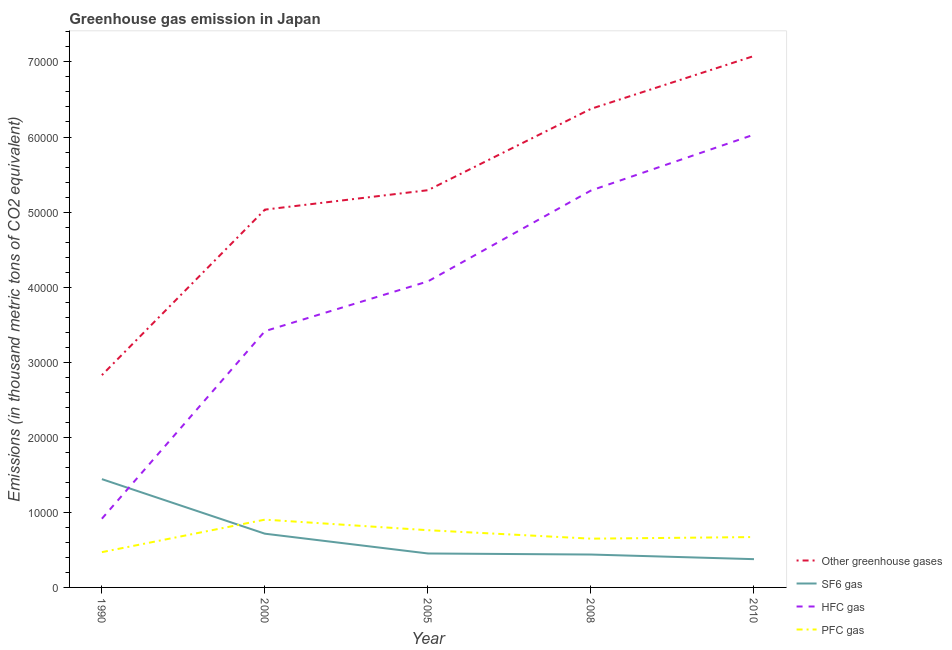Does the line corresponding to emission of hfc gas intersect with the line corresponding to emission of sf6 gas?
Give a very brief answer. Yes. What is the emission of greenhouse gases in 2005?
Offer a very short reply. 5.29e+04. Across all years, what is the maximum emission of pfc gas?
Your response must be concise. 9029.8. Across all years, what is the minimum emission of sf6 gas?
Your answer should be compact. 3765. In which year was the emission of hfc gas maximum?
Offer a terse response. 2010. What is the total emission of greenhouse gases in the graph?
Offer a very short reply. 2.66e+05. What is the difference between the emission of greenhouse gases in 1990 and that in 2010?
Give a very brief answer. -4.25e+04. What is the difference between the emission of pfc gas in 2010 and the emission of hfc gas in 1990?
Provide a short and direct response. -2444.3. What is the average emission of greenhouse gases per year?
Your answer should be very brief. 5.32e+04. In the year 2000, what is the difference between the emission of hfc gas and emission of pfc gas?
Give a very brief answer. 2.51e+04. In how many years, is the emission of sf6 gas greater than 6000 thousand metric tons?
Your answer should be compact. 2. What is the ratio of the emission of hfc gas in 2008 to that in 2010?
Give a very brief answer. 0.88. Is the difference between the emission of greenhouse gases in 2000 and 2008 greater than the difference between the emission of sf6 gas in 2000 and 2008?
Provide a short and direct response. No. What is the difference between the highest and the second highest emission of pfc gas?
Your response must be concise. 1406.2. What is the difference between the highest and the lowest emission of pfc gas?
Give a very brief answer. 4329.8. In how many years, is the emission of pfc gas greater than the average emission of pfc gas taken over all years?
Provide a short and direct response. 2. Is the sum of the emission of hfc gas in 1990 and 2000 greater than the maximum emission of sf6 gas across all years?
Provide a short and direct response. Yes. Is it the case that in every year, the sum of the emission of greenhouse gases and emission of hfc gas is greater than the sum of emission of pfc gas and emission of sf6 gas?
Keep it short and to the point. Yes. Does the emission of greenhouse gases monotonically increase over the years?
Your answer should be compact. Yes. Is the emission of pfc gas strictly less than the emission of sf6 gas over the years?
Offer a very short reply. No. How many lines are there?
Keep it short and to the point. 4. How many years are there in the graph?
Give a very brief answer. 5. Does the graph contain grids?
Offer a terse response. No. What is the title of the graph?
Ensure brevity in your answer.  Greenhouse gas emission in Japan. What is the label or title of the X-axis?
Give a very brief answer. Year. What is the label or title of the Y-axis?
Your answer should be compact. Emissions (in thousand metric tons of CO2 equivalent). What is the Emissions (in thousand metric tons of CO2 equivalent) of Other greenhouse gases in 1990?
Your answer should be compact. 2.83e+04. What is the Emissions (in thousand metric tons of CO2 equivalent) of SF6 gas in 1990?
Provide a succinct answer. 1.44e+04. What is the Emissions (in thousand metric tons of CO2 equivalent) of HFC gas in 1990?
Offer a terse response. 9154.3. What is the Emissions (in thousand metric tons of CO2 equivalent) of PFC gas in 1990?
Give a very brief answer. 4700. What is the Emissions (in thousand metric tons of CO2 equivalent) in Other greenhouse gases in 2000?
Your answer should be compact. 5.03e+04. What is the Emissions (in thousand metric tons of CO2 equivalent) in SF6 gas in 2000?
Offer a terse response. 7156.6. What is the Emissions (in thousand metric tons of CO2 equivalent) in HFC gas in 2000?
Ensure brevity in your answer.  3.41e+04. What is the Emissions (in thousand metric tons of CO2 equivalent) of PFC gas in 2000?
Keep it short and to the point. 9029.8. What is the Emissions (in thousand metric tons of CO2 equivalent) in Other greenhouse gases in 2005?
Your answer should be very brief. 5.29e+04. What is the Emissions (in thousand metric tons of CO2 equivalent) of SF6 gas in 2005?
Ensure brevity in your answer.  4522.3. What is the Emissions (in thousand metric tons of CO2 equivalent) of HFC gas in 2005?
Your response must be concise. 4.08e+04. What is the Emissions (in thousand metric tons of CO2 equivalent) in PFC gas in 2005?
Provide a succinct answer. 7623.6. What is the Emissions (in thousand metric tons of CO2 equivalent) in Other greenhouse gases in 2008?
Keep it short and to the point. 6.38e+04. What is the Emissions (in thousand metric tons of CO2 equivalent) in SF6 gas in 2008?
Provide a short and direct response. 4382.7. What is the Emissions (in thousand metric tons of CO2 equivalent) in HFC gas in 2008?
Keep it short and to the point. 5.29e+04. What is the Emissions (in thousand metric tons of CO2 equivalent) of PFC gas in 2008?
Ensure brevity in your answer.  6496.1. What is the Emissions (in thousand metric tons of CO2 equivalent) of Other greenhouse gases in 2010?
Your answer should be very brief. 7.08e+04. What is the Emissions (in thousand metric tons of CO2 equivalent) of SF6 gas in 2010?
Your response must be concise. 3765. What is the Emissions (in thousand metric tons of CO2 equivalent) in HFC gas in 2010?
Make the answer very short. 6.03e+04. What is the Emissions (in thousand metric tons of CO2 equivalent) in PFC gas in 2010?
Your response must be concise. 6710. Across all years, what is the maximum Emissions (in thousand metric tons of CO2 equivalent) of Other greenhouse gases?
Provide a short and direct response. 7.08e+04. Across all years, what is the maximum Emissions (in thousand metric tons of CO2 equivalent) of SF6 gas?
Your answer should be compact. 1.44e+04. Across all years, what is the maximum Emissions (in thousand metric tons of CO2 equivalent) in HFC gas?
Make the answer very short. 6.03e+04. Across all years, what is the maximum Emissions (in thousand metric tons of CO2 equivalent) in PFC gas?
Your answer should be very brief. 9029.8. Across all years, what is the minimum Emissions (in thousand metric tons of CO2 equivalent) in Other greenhouse gases?
Provide a succinct answer. 2.83e+04. Across all years, what is the minimum Emissions (in thousand metric tons of CO2 equivalent) in SF6 gas?
Keep it short and to the point. 3765. Across all years, what is the minimum Emissions (in thousand metric tons of CO2 equivalent) in HFC gas?
Ensure brevity in your answer.  9154.3. Across all years, what is the minimum Emissions (in thousand metric tons of CO2 equivalent) in PFC gas?
Your answer should be very brief. 4700. What is the total Emissions (in thousand metric tons of CO2 equivalent) of Other greenhouse gases in the graph?
Your response must be concise. 2.66e+05. What is the total Emissions (in thousand metric tons of CO2 equivalent) of SF6 gas in the graph?
Make the answer very short. 3.43e+04. What is the total Emissions (in thousand metric tons of CO2 equivalent) in HFC gas in the graph?
Offer a very short reply. 1.97e+05. What is the total Emissions (in thousand metric tons of CO2 equivalent) of PFC gas in the graph?
Provide a succinct answer. 3.46e+04. What is the difference between the Emissions (in thousand metric tons of CO2 equivalent) in Other greenhouse gases in 1990 and that in 2000?
Your answer should be compact. -2.20e+04. What is the difference between the Emissions (in thousand metric tons of CO2 equivalent) in SF6 gas in 1990 and that in 2000?
Your answer should be very brief. 7269.2. What is the difference between the Emissions (in thousand metric tons of CO2 equivalent) of HFC gas in 1990 and that in 2000?
Your response must be concise. -2.50e+04. What is the difference between the Emissions (in thousand metric tons of CO2 equivalent) of PFC gas in 1990 and that in 2000?
Your answer should be very brief. -4329.8. What is the difference between the Emissions (in thousand metric tons of CO2 equivalent) of Other greenhouse gases in 1990 and that in 2005?
Provide a succinct answer. -2.46e+04. What is the difference between the Emissions (in thousand metric tons of CO2 equivalent) in SF6 gas in 1990 and that in 2005?
Provide a succinct answer. 9903.5. What is the difference between the Emissions (in thousand metric tons of CO2 equivalent) in HFC gas in 1990 and that in 2005?
Offer a terse response. -3.16e+04. What is the difference between the Emissions (in thousand metric tons of CO2 equivalent) in PFC gas in 1990 and that in 2005?
Make the answer very short. -2923.6. What is the difference between the Emissions (in thousand metric tons of CO2 equivalent) in Other greenhouse gases in 1990 and that in 2008?
Provide a short and direct response. -3.55e+04. What is the difference between the Emissions (in thousand metric tons of CO2 equivalent) of SF6 gas in 1990 and that in 2008?
Offer a terse response. 1.00e+04. What is the difference between the Emissions (in thousand metric tons of CO2 equivalent) of HFC gas in 1990 and that in 2008?
Offer a terse response. -4.37e+04. What is the difference between the Emissions (in thousand metric tons of CO2 equivalent) of PFC gas in 1990 and that in 2008?
Your answer should be very brief. -1796.1. What is the difference between the Emissions (in thousand metric tons of CO2 equivalent) in Other greenhouse gases in 1990 and that in 2010?
Your answer should be compact. -4.25e+04. What is the difference between the Emissions (in thousand metric tons of CO2 equivalent) of SF6 gas in 1990 and that in 2010?
Ensure brevity in your answer.  1.07e+04. What is the difference between the Emissions (in thousand metric tons of CO2 equivalent) in HFC gas in 1990 and that in 2010?
Your response must be concise. -5.12e+04. What is the difference between the Emissions (in thousand metric tons of CO2 equivalent) in PFC gas in 1990 and that in 2010?
Give a very brief answer. -2010. What is the difference between the Emissions (in thousand metric tons of CO2 equivalent) in Other greenhouse gases in 2000 and that in 2005?
Give a very brief answer. -2588.2. What is the difference between the Emissions (in thousand metric tons of CO2 equivalent) in SF6 gas in 2000 and that in 2005?
Offer a very short reply. 2634.3. What is the difference between the Emissions (in thousand metric tons of CO2 equivalent) of HFC gas in 2000 and that in 2005?
Give a very brief answer. -6628.7. What is the difference between the Emissions (in thousand metric tons of CO2 equivalent) in PFC gas in 2000 and that in 2005?
Ensure brevity in your answer.  1406.2. What is the difference between the Emissions (in thousand metric tons of CO2 equivalent) of Other greenhouse gases in 2000 and that in 2008?
Your answer should be very brief. -1.34e+04. What is the difference between the Emissions (in thousand metric tons of CO2 equivalent) in SF6 gas in 2000 and that in 2008?
Your answer should be compact. 2773.9. What is the difference between the Emissions (in thousand metric tons of CO2 equivalent) in HFC gas in 2000 and that in 2008?
Your answer should be very brief. -1.87e+04. What is the difference between the Emissions (in thousand metric tons of CO2 equivalent) of PFC gas in 2000 and that in 2008?
Your answer should be very brief. 2533.7. What is the difference between the Emissions (in thousand metric tons of CO2 equivalent) in Other greenhouse gases in 2000 and that in 2010?
Provide a succinct answer. -2.05e+04. What is the difference between the Emissions (in thousand metric tons of CO2 equivalent) of SF6 gas in 2000 and that in 2010?
Give a very brief answer. 3391.6. What is the difference between the Emissions (in thousand metric tons of CO2 equivalent) of HFC gas in 2000 and that in 2010?
Keep it short and to the point. -2.62e+04. What is the difference between the Emissions (in thousand metric tons of CO2 equivalent) of PFC gas in 2000 and that in 2010?
Make the answer very short. 2319.8. What is the difference between the Emissions (in thousand metric tons of CO2 equivalent) in Other greenhouse gases in 2005 and that in 2008?
Ensure brevity in your answer.  -1.08e+04. What is the difference between the Emissions (in thousand metric tons of CO2 equivalent) of SF6 gas in 2005 and that in 2008?
Offer a terse response. 139.6. What is the difference between the Emissions (in thousand metric tons of CO2 equivalent) in HFC gas in 2005 and that in 2008?
Offer a terse response. -1.21e+04. What is the difference between the Emissions (in thousand metric tons of CO2 equivalent) in PFC gas in 2005 and that in 2008?
Your response must be concise. 1127.5. What is the difference between the Emissions (in thousand metric tons of CO2 equivalent) of Other greenhouse gases in 2005 and that in 2010?
Your response must be concise. -1.79e+04. What is the difference between the Emissions (in thousand metric tons of CO2 equivalent) of SF6 gas in 2005 and that in 2010?
Make the answer very short. 757.3. What is the difference between the Emissions (in thousand metric tons of CO2 equivalent) in HFC gas in 2005 and that in 2010?
Provide a short and direct response. -1.95e+04. What is the difference between the Emissions (in thousand metric tons of CO2 equivalent) of PFC gas in 2005 and that in 2010?
Your response must be concise. 913.6. What is the difference between the Emissions (in thousand metric tons of CO2 equivalent) in Other greenhouse gases in 2008 and that in 2010?
Offer a very short reply. -7042.3. What is the difference between the Emissions (in thousand metric tons of CO2 equivalent) of SF6 gas in 2008 and that in 2010?
Your response must be concise. 617.7. What is the difference between the Emissions (in thousand metric tons of CO2 equivalent) in HFC gas in 2008 and that in 2010?
Keep it short and to the point. -7446.1. What is the difference between the Emissions (in thousand metric tons of CO2 equivalent) in PFC gas in 2008 and that in 2010?
Your answer should be compact. -213.9. What is the difference between the Emissions (in thousand metric tons of CO2 equivalent) of Other greenhouse gases in 1990 and the Emissions (in thousand metric tons of CO2 equivalent) of SF6 gas in 2000?
Offer a terse response. 2.11e+04. What is the difference between the Emissions (in thousand metric tons of CO2 equivalent) of Other greenhouse gases in 1990 and the Emissions (in thousand metric tons of CO2 equivalent) of HFC gas in 2000?
Make the answer very short. -5859.7. What is the difference between the Emissions (in thousand metric tons of CO2 equivalent) of Other greenhouse gases in 1990 and the Emissions (in thousand metric tons of CO2 equivalent) of PFC gas in 2000?
Ensure brevity in your answer.  1.93e+04. What is the difference between the Emissions (in thousand metric tons of CO2 equivalent) in SF6 gas in 1990 and the Emissions (in thousand metric tons of CO2 equivalent) in HFC gas in 2000?
Your answer should be compact. -1.97e+04. What is the difference between the Emissions (in thousand metric tons of CO2 equivalent) in SF6 gas in 1990 and the Emissions (in thousand metric tons of CO2 equivalent) in PFC gas in 2000?
Provide a succinct answer. 5396. What is the difference between the Emissions (in thousand metric tons of CO2 equivalent) in HFC gas in 1990 and the Emissions (in thousand metric tons of CO2 equivalent) in PFC gas in 2000?
Your answer should be very brief. 124.5. What is the difference between the Emissions (in thousand metric tons of CO2 equivalent) in Other greenhouse gases in 1990 and the Emissions (in thousand metric tons of CO2 equivalent) in SF6 gas in 2005?
Make the answer very short. 2.38e+04. What is the difference between the Emissions (in thousand metric tons of CO2 equivalent) of Other greenhouse gases in 1990 and the Emissions (in thousand metric tons of CO2 equivalent) of HFC gas in 2005?
Give a very brief answer. -1.25e+04. What is the difference between the Emissions (in thousand metric tons of CO2 equivalent) of Other greenhouse gases in 1990 and the Emissions (in thousand metric tons of CO2 equivalent) of PFC gas in 2005?
Keep it short and to the point. 2.07e+04. What is the difference between the Emissions (in thousand metric tons of CO2 equivalent) of SF6 gas in 1990 and the Emissions (in thousand metric tons of CO2 equivalent) of HFC gas in 2005?
Offer a terse response. -2.63e+04. What is the difference between the Emissions (in thousand metric tons of CO2 equivalent) in SF6 gas in 1990 and the Emissions (in thousand metric tons of CO2 equivalent) in PFC gas in 2005?
Offer a very short reply. 6802.2. What is the difference between the Emissions (in thousand metric tons of CO2 equivalent) of HFC gas in 1990 and the Emissions (in thousand metric tons of CO2 equivalent) of PFC gas in 2005?
Your response must be concise. 1530.7. What is the difference between the Emissions (in thousand metric tons of CO2 equivalent) in Other greenhouse gases in 1990 and the Emissions (in thousand metric tons of CO2 equivalent) in SF6 gas in 2008?
Your answer should be very brief. 2.39e+04. What is the difference between the Emissions (in thousand metric tons of CO2 equivalent) of Other greenhouse gases in 1990 and the Emissions (in thousand metric tons of CO2 equivalent) of HFC gas in 2008?
Offer a terse response. -2.46e+04. What is the difference between the Emissions (in thousand metric tons of CO2 equivalent) in Other greenhouse gases in 1990 and the Emissions (in thousand metric tons of CO2 equivalent) in PFC gas in 2008?
Keep it short and to the point. 2.18e+04. What is the difference between the Emissions (in thousand metric tons of CO2 equivalent) of SF6 gas in 1990 and the Emissions (in thousand metric tons of CO2 equivalent) of HFC gas in 2008?
Your answer should be very brief. -3.84e+04. What is the difference between the Emissions (in thousand metric tons of CO2 equivalent) of SF6 gas in 1990 and the Emissions (in thousand metric tons of CO2 equivalent) of PFC gas in 2008?
Offer a very short reply. 7929.7. What is the difference between the Emissions (in thousand metric tons of CO2 equivalent) in HFC gas in 1990 and the Emissions (in thousand metric tons of CO2 equivalent) in PFC gas in 2008?
Ensure brevity in your answer.  2658.2. What is the difference between the Emissions (in thousand metric tons of CO2 equivalent) of Other greenhouse gases in 1990 and the Emissions (in thousand metric tons of CO2 equivalent) of SF6 gas in 2010?
Provide a short and direct response. 2.45e+04. What is the difference between the Emissions (in thousand metric tons of CO2 equivalent) in Other greenhouse gases in 1990 and the Emissions (in thousand metric tons of CO2 equivalent) in HFC gas in 2010?
Ensure brevity in your answer.  -3.20e+04. What is the difference between the Emissions (in thousand metric tons of CO2 equivalent) in Other greenhouse gases in 1990 and the Emissions (in thousand metric tons of CO2 equivalent) in PFC gas in 2010?
Make the answer very short. 2.16e+04. What is the difference between the Emissions (in thousand metric tons of CO2 equivalent) in SF6 gas in 1990 and the Emissions (in thousand metric tons of CO2 equivalent) in HFC gas in 2010?
Make the answer very short. -4.59e+04. What is the difference between the Emissions (in thousand metric tons of CO2 equivalent) of SF6 gas in 1990 and the Emissions (in thousand metric tons of CO2 equivalent) of PFC gas in 2010?
Ensure brevity in your answer.  7715.8. What is the difference between the Emissions (in thousand metric tons of CO2 equivalent) of HFC gas in 1990 and the Emissions (in thousand metric tons of CO2 equivalent) of PFC gas in 2010?
Give a very brief answer. 2444.3. What is the difference between the Emissions (in thousand metric tons of CO2 equivalent) in Other greenhouse gases in 2000 and the Emissions (in thousand metric tons of CO2 equivalent) in SF6 gas in 2005?
Ensure brevity in your answer.  4.58e+04. What is the difference between the Emissions (in thousand metric tons of CO2 equivalent) of Other greenhouse gases in 2000 and the Emissions (in thousand metric tons of CO2 equivalent) of HFC gas in 2005?
Your answer should be very brief. 9557.7. What is the difference between the Emissions (in thousand metric tons of CO2 equivalent) in Other greenhouse gases in 2000 and the Emissions (in thousand metric tons of CO2 equivalent) in PFC gas in 2005?
Give a very brief answer. 4.27e+04. What is the difference between the Emissions (in thousand metric tons of CO2 equivalent) of SF6 gas in 2000 and the Emissions (in thousand metric tons of CO2 equivalent) of HFC gas in 2005?
Your response must be concise. -3.36e+04. What is the difference between the Emissions (in thousand metric tons of CO2 equivalent) of SF6 gas in 2000 and the Emissions (in thousand metric tons of CO2 equivalent) of PFC gas in 2005?
Offer a terse response. -467. What is the difference between the Emissions (in thousand metric tons of CO2 equivalent) of HFC gas in 2000 and the Emissions (in thousand metric tons of CO2 equivalent) of PFC gas in 2005?
Make the answer very short. 2.65e+04. What is the difference between the Emissions (in thousand metric tons of CO2 equivalent) in Other greenhouse gases in 2000 and the Emissions (in thousand metric tons of CO2 equivalent) in SF6 gas in 2008?
Provide a short and direct response. 4.59e+04. What is the difference between the Emissions (in thousand metric tons of CO2 equivalent) of Other greenhouse gases in 2000 and the Emissions (in thousand metric tons of CO2 equivalent) of HFC gas in 2008?
Make the answer very short. -2545.7. What is the difference between the Emissions (in thousand metric tons of CO2 equivalent) in Other greenhouse gases in 2000 and the Emissions (in thousand metric tons of CO2 equivalent) in PFC gas in 2008?
Your response must be concise. 4.38e+04. What is the difference between the Emissions (in thousand metric tons of CO2 equivalent) of SF6 gas in 2000 and the Emissions (in thousand metric tons of CO2 equivalent) of HFC gas in 2008?
Your response must be concise. -4.57e+04. What is the difference between the Emissions (in thousand metric tons of CO2 equivalent) in SF6 gas in 2000 and the Emissions (in thousand metric tons of CO2 equivalent) in PFC gas in 2008?
Offer a terse response. 660.5. What is the difference between the Emissions (in thousand metric tons of CO2 equivalent) of HFC gas in 2000 and the Emissions (in thousand metric tons of CO2 equivalent) of PFC gas in 2008?
Provide a succinct answer. 2.76e+04. What is the difference between the Emissions (in thousand metric tons of CO2 equivalent) of Other greenhouse gases in 2000 and the Emissions (in thousand metric tons of CO2 equivalent) of SF6 gas in 2010?
Provide a succinct answer. 4.66e+04. What is the difference between the Emissions (in thousand metric tons of CO2 equivalent) in Other greenhouse gases in 2000 and the Emissions (in thousand metric tons of CO2 equivalent) in HFC gas in 2010?
Your response must be concise. -9991.8. What is the difference between the Emissions (in thousand metric tons of CO2 equivalent) in Other greenhouse gases in 2000 and the Emissions (in thousand metric tons of CO2 equivalent) in PFC gas in 2010?
Make the answer very short. 4.36e+04. What is the difference between the Emissions (in thousand metric tons of CO2 equivalent) of SF6 gas in 2000 and the Emissions (in thousand metric tons of CO2 equivalent) of HFC gas in 2010?
Your response must be concise. -5.32e+04. What is the difference between the Emissions (in thousand metric tons of CO2 equivalent) of SF6 gas in 2000 and the Emissions (in thousand metric tons of CO2 equivalent) of PFC gas in 2010?
Make the answer very short. 446.6. What is the difference between the Emissions (in thousand metric tons of CO2 equivalent) of HFC gas in 2000 and the Emissions (in thousand metric tons of CO2 equivalent) of PFC gas in 2010?
Your response must be concise. 2.74e+04. What is the difference between the Emissions (in thousand metric tons of CO2 equivalent) in Other greenhouse gases in 2005 and the Emissions (in thousand metric tons of CO2 equivalent) in SF6 gas in 2008?
Ensure brevity in your answer.  4.85e+04. What is the difference between the Emissions (in thousand metric tons of CO2 equivalent) of Other greenhouse gases in 2005 and the Emissions (in thousand metric tons of CO2 equivalent) of HFC gas in 2008?
Offer a very short reply. 42.5. What is the difference between the Emissions (in thousand metric tons of CO2 equivalent) of Other greenhouse gases in 2005 and the Emissions (in thousand metric tons of CO2 equivalent) of PFC gas in 2008?
Keep it short and to the point. 4.64e+04. What is the difference between the Emissions (in thousand metric tons of CO2 equivalent) in SF6 gas in 2005 and the Emissions (in thousand metric tons of CO2 equivalent) in HFC gas in 2008?
Keep it short and to the point. -4.83e+04. What is the difference between the Emissions (in thousand metric tons of CO2 equivalent) in SF6 gas in 2005 and the Emissions (in thousand metric tons of CO2 equivalent) in PFC gas in 2008?
Offer a terse response. -1973.8. What is the difference between the Emissions (in thousand metric tons of CO2 equivalent) in HFC gas in 2005 and the Emissions (in thousand metric tons of CO2 equivalent) in PFC gas in 2008?
Your answer should be very brief. 3.43e+04. What is the difference between the Emissions (in thousand metric tons of CO2 equivalent) in Other greenhouse gases in 2005 and the Emissions (in thousand metric tons of CO2 equivalent) in SF6 gas in 2010?
Offer a very short reply. 4.91e+04. What is the difference between the Emissions (in thousand metric tons of CO2 equivalent) of Other greenhouse gases in 2005 and the Emissions (in thousand metric tons of CO2 equivalent) of HFC gas in 2010?
Your response must be concise. -7403.6. What is the difference between the Emissions (in thousand metric tons of CO2 equivalent) of Other greenhouse gases in 2005 and the Emissions (in thousand metric tons of CO2 equivalent) of PFC gas in 2010?
Offer a terse response. 4.62e+04. What is the difference between the Emissions (in thousand metric tons of CO2 equivalent) in SF6 gas in 2005 and the Emissions (in thousand metric tons of CO2 equivalent) in HFC gas in 2010?
Your answer should be very brief. -5.58e+04. What is the difference between the Emissions (in thousand metric tons of CO2 equivalent) in SF6 gas in 2005 and the Emissions (in thousand metric tons of CO2 equivalent) in PFC gas in 2010?
Keep it short and to the point. -2187.7. What is the difference between the Emissions (in thousand metric tons of CO2 equivalent) in HFC gas in 2005 and the Emissions (in thousand metric tons of CO2 equivalent) in PFC gas in 2010?
Your response must be concise. 3.41e+04. What is the difference between the Emissions (in thousand metric tons of CO2 equivalent) of Other greenhouse gases in 2008 and the Emissions (in thousand metric tons of CO2 equivalent) of SF6 gas in 2010?
Make the answer very short. 6.00e+04. What is the difference between the Emissions (in thousand metric tons of CO2 equivalent) in Other greenhouse gases in 2008 and the Emissions (in thousand metric tons of CO2 equivalent) in HFC gas in 2010?
Your answer should be very brief. 3432.7. What is the difference between the Emissions (in thousand metric tons of CO2 equivalent) in Other greenhouse gases in 2008 and the Emissions (in thousand metric tons of CO2 equivalent) in PFC gas in 2010?
Ensure brevity in your answer.  5.70e+04. What is the difference between the Emissions (in thousand metric tons of CO2 equivalent) of SF6 gas in 2008 and the Emissions (in thousand metric tons of CO2 equivalent) of HFC gas in 2010?
Provide a short and direct response. -5.59e+04. What is the difference between the Emissions (in thousand metric tons of CO2 equivalent) of SF6 gas in 2008 and the Emissions (in thousand metric tons of CO2 equivalent) of PFC gas in 2010?
Make the answer very short. -2327.3. What is the difference between the Emissions (in thousand metric tons of CO2 equivalent) in HFC gas in 2008 and the Emissions (in thousand metric tons of CO2 equivalent) in PFC gas in 2010?
Give a very brief answer. 4.62e+04. What is the average Emissions (in thousand metric tons of CO2 equivalent) of Other greenhouse gases per year?
Your answer should be compact. 5.32e+04. What is the average Emissions (in thousand metric tons of CO2 equivalent) of SF6 gas per year?
Offer a very short reply. 6850.48. What is the average Emissions (in thousand metric tons of CO2 equivalent) in HFC gas per year?
Keep it short and to the point. 3.95e+04. What is the average Emissions (in thousand metric tons of CO2 equivalent) of PFC gas per year?
Provide a succinct answer. 6911.9. In the year 1990, what is the difference between the Emissions (in thousand metric tons of CO2 equivalent) of Other greenhouse gases and Emissions (in thousand metric tons of CO2 equivalent) of SF6 gas?
Keep it short and to the point. 1.39e+04. In the year 1990, what is the difference between the Emissions (in thousand metric tons of CO2 equivalent) in Other greenhouse gases and Emissions (in thousand metric tons of CO2 equivalent) in HFC gas?
Offer a very short reply. 1.91e+04. In the year 1990, what is the difference between the Emissions (in thousand metric tons of CO2 equivalent) of Other greenhouse gases and Emissions (in thousand metric tons of CO2 equivalent) of PFC gas?
Give a very brief answer. 2.36e+04. In the year 1990, what is the difference between the Emissions (in thousand metric tons of CO2 equivalent) in SF6 gas and Emissions (in thousand metric tons of CO2 equivalent) in HFC gas?
Give a very brief answer. 5271.5. In the year 1990, what is the difference between the Emissions (in thousand metric tons of CO2 equivalent) of SF6 gas and Emissions (in thousand metric tons of CO2 equivalent) of PFC gas?
Offer a terse response. 9725.8. In the year 1990, what is the difference between the Emissions (in thousand metric tons of CO2 equivalent) in HFC gas and Emissions (in thousand metric tons of CO2 equivalent) in PFC gas?
Provide a short and direct response. 4454.3. In the year 2000, what is the difference between the Emissions (in thousand metric tons of CO2 equivalent) of Other greenhouse gases and Emissions (in thousand metric tons of CO2 equivalent) of SF6 gas?
Keep it short and to the point. 4.32e+04. In the year 2000, what is the difference between the Emissions (in thousand metric tons of CO2 equivalent) of Other greenhouse gases and Emissions (in thousand metric tons of CO2 equivalent) of HFC gas?
Offer a terse response. 1.62e+04. In the year 2000, what is the difference between the Emissions (in thousand metric tons of CO2 equivalent) in Other greenhouse gases and Emissions (in thousand metric tons of CO2 equivalent) in PFC gas?
Provide a succinct answer. 4.13e+04. In the year 2000, what is the difference between the Emissions (in thousand metric tons of CO2 equivalent) of SF6 gas and Emissions (in thousand metric tons of CO2 equivalent) of HFC gas?
Provide a succinct answer. -2.70e+04. In the year 2000, what is the difference between the Emissions (in thousand metric tons of CO2 equivalent) in SF6 gas and Emissions (in thousand metric tons of CO2 equivalent) in PFC gas?
Provide a succinct answer. -1873.2. In the year 2000, what is the difference between the Emissions (in thousand metric tons of CO2 equivalent) of HFC gas and Emissions (in thousand metric tons of CO2 equivalent) of PFC gas?
Make the answer very short. 2.51e+04. In the year 2005, what is the difference between the Emissions (in thousand metric tons of CO2 equivalent) of Other greenhouse gases and Emissions (in thousand metric tons of CO2 equivalent) of SF6 gas?
Give a very brief answer. 4.84e+04. In the year 2005, what is the difference between the Emissions (in thousand metric tons of CO2 equivalent) in Other greenhouse gases and Emissions (in thousand metric tons of CO2 equivalent) in HFC gas?
Your response must be concise. 1.21e+04. In the year 2005, what is the difference between the Emissions (in thousand metric tons of CO2 equivalent) of Other greenhouse gases and Emissions (in thousand metric tons of CO2 equivalent) of PFC gas?
Offer a terse response. 4.53e+04. In the year 2005, what is the difference between the Emissions (in thousand metric tons of CO2 equivalent) of SF6 gas and Emissions (in thousand metric tons of CO2 equivalent) of HFC gas?
Make the answer very short. -3.62e+04. In the year 2005, what is the difference between the Emissions (in thousand metric tons of CO2 equivalent) of SF6 gas and Emissions (in thousand metric tons of CO2 equivalent) of PFC gas?
Your answer should be very brief. -3101.3. In the year 2005, what is the difference between the Emissions (in thousand metric tons of CO2 equivalent) of HFC gas and Emissions (in thousand metric tons of CO2 equivalent) of PFC gas?
Make the answer very short. 3.31e+04. In the year 2008, what is the difference between the Emissions (in thousand metric tons of CO2 equivalent) in Other greenhouse gases and Emissions (in thousand metric tons of CO2 equivalent) in SF6 gas?
Offer a very short reply. 5.94e+04. In the year 2008, what is the difference between the Emissions (in thousand metric tons of CO2 equivalent) of Other greenhouse gases and Emissions (in thousand metric tons of CO2 equivalent) of HFC gas?
Your response must be concise. 1.09e+04. In the year 2008, what is the difference between the Emissions (in thousand metric tons of CO2 equivalent) in Other greenhouse gases and Emissions (in thousand metric tons of CO2 equivalent) in PFC gas?
Give a very brief answer. 5.73e+04. In the year 2008, what is the difference between the Emissions (in thousand metric tons of CO2 equivalent) in SF6 gas and Emissions (in thousand metric tons of CO2 equivalent) in HFC gas?
Offer a terse response. -4.85e+04. In the year 2008, what is the difference between the Emissions (in thousand metric tons of CO2 equivalent) of SF6 gas and Emissions (in thousand metric tons of CO2 equivalent) of PFC gas?
Make the answer very short. -2113.4. In the year 2008, what is the difference between the Emissions (in thousand metric tons of CO2 equivalent) of HFC gas and Emissions (in thousand metric tons of CO2 equivalent) of PFC gas?
Offer a terse response. 4.64e+04. In the year 2010, what is the difference between the Emissions (in thousand metric tons of CO2 equivalent) in Other greenhouse gases and Emissions (in thousand metric tons of CO2 equivalent) in SF6 gas?
Make the answer very short. 6.70e+04. In the year 2010, what is the difference between the Emissions (in thousand metric tons of CO2 equivalent) in Other greenhouse gases and Emissions (in thousand metric tons of CO2 equivalent) in HFC gas?
Provide a succinct answer. 1.05e+04. In the year 2010, what is the difference between the Emissions (in thousand metric tons of CO2 equivalent) in Other greenhouse gases and Emissions (in thousand metric tons of CO2 equivalent) in PFC gas?
Provide a short and direct response. 6.41e+04. In the year 2010, what is the difference between the Emissions (in thousand metric tons of CO2 equivalent) in SF6 gas and Emissions (in thousand metric tons of CO2 equivalent) in HFC gas?
Your answer should be compact. -5.66e+04. In the year 2010, what is the difference between the Emissions (in thousand metric tons of CO2 equivalent) of SF6 gas and Emissions (in thousand metric tons of CO2 equivalent) of PFC gas?
Provide a succinct answer. -2945. In the year 2010, what is the difference between the Emissions (in thousand metric tons of CO2 equivalent) in HFC gas and Emissions (in thousand metric tons of CO2 equivalent) in PFC gas?
Provide a short and direct response. 5.36e+04. What is the ratio of the Emissions (in thousand metric tons of CO2 equivalent) of Other greenhouse gases in 1990 to that in 2000?
Ensure brevity in your answer.  0.56. What is the ratio of the Emissions (in thousand metric tons of CO2 equivalent) in SF6 gas in 1990 to that in 2000?
Your response must be concise. 2.02. What is the ratio of the Emissions (in thousand metric tons of CO2 equivalent) in HFC gas in 1990 to that in 2000?
Offer a terse response. 0.27. What is the ratio of the Emissions (in thousand metric tons of CO2 equivalent) in PFC gas in 1990 to that in 2000?
Provide a short and direct response. 0.52. What is the ratio of the Emissions (in thousand metric tons of CO2 equivalent) in Other greenhouse gases in 1990 to that in 2005?
Offer a terse response. 0.53. What is the ratio of the Emissions (in thousand metric tons of CO2 equivalent) of SF6 gas in 1990 to that in 2005?
Your answer should be compact. 3.19. What is the ratio of the Emissions (in thousand metric tons of CO2 equivalent) in HFC gas in 1990 to that in 2005?
Provide a short and direct response. 0.22. What is the ratio of the Emissions (in thousand metric tons of CO2 equivalent) of PFC gas in 1990 to that in 2005?
Your answer should be compact. 0.62. What is the ratio of the Emissions (in thousand metric tons of CO2 equivalent) of Other greenhouse gases in 1990 to that in 2008?
Give a very brief answer. 0.44. What is the ratio of the Emissions (in thousand metric tons of CO2 equivalent) in SF6 gas in 1990 to that in 2008?
Provide a short and direct response. 3.29. What is the ratio of the Emissions (in thousand metric tons of CO2 equivalent) of HFC gas in 1990 to that in 2008?
Provide a short and direct response. 0.17. What is the ratio of the Emissions (in thousand metric tons of CO2 equivalent) in PFC gas in 1990 to that in 2008?
Offer a terse response. 0.72. What is the ratio of the Emissions (in thousand metric tons of CO2 equivalent) in Other greenhouse gases in 1990 to that in 2010?
Your answer should be very brief. 0.4. What is the ratio of the Emissions (in thousand metric tons of CO2 equivalent) of SF6 gas in 1990 to that in 2010?
Your answer should be very brief. 3.83. What is the ratio of the Emissions (in thousand metric tons of CO2 equivalent) in HFC gas in 1990 to that in 2010?
Give a very brief answer. 0.15. What is the ratio of the Emissions (in thousand metric tons of CO2 equivalent) of PFC gas in 1990 to that in 2010?
Offer a terse response. 0.7. What is the ratio of the Emissions (in thousand metric tons of CO2 equivalent) of Other greenhouse gases in 2000 to that in 2005?
Offer a very short reply. 0.95. What is the ratio of the Emissions (in thousand metric tons of CO2 equivalent) of SF6 gas in 2000 to that in 2005?
Offer a very short reply. 1.58. What is the ratio of the Emissions (in thousand metric tons of CO2 equivalent) in HFC gas in 2000 to that in 2005?
Your answer should be very brief. 0.84. What is the ratio of the Emissions (in thousand metric tons of CO2 equivalent) in PFC gas in 2000 to that in 2005?
Ensure brevity in your answer.  1.18. What is the ratio of the Emissions (in thousand metric tons of CO2 equivalent) in Other greenhouse gases in 2000 to that in 2008?
Provide a succinct answer. 0.79. What is the ratio of the Emissions (in thousand metric tons of CO2 equivalent) in SF6 gas in 2000 to that in 2008?
Provide a succinct answer. 1.63. What is the ratio of the Emissions (in thousand metric tons of CO2 equivalent) of HFC gas in 2000 to that in 2008?
Your answer should be very brief. 0.65. What is the ratio of the Emissions (in thousand metric tons of CO2 equivalent) in PFC gas in 2000 to that in 2008?
Make the answer very short. 1.39. What is the ratio of the Emissions (in thousand metric tons of CO2 equivalent) in Other greenhouse gases in 2000 to that in 2010?
Provide a succinct answer. 0.71. What is the ratio of the Emissions (in thousand metric tons of CO2 equivalent) of SF6 gas in 2000 to that in 2010?
Provide a short and direct response. 1.9. What is the ratio of the Emissions (in thousand metric tons of CO2 equivalent) of HFC gas in 2000 to that in 2010?
Offer a terse response. 0.57. What is the ratio of the Emissions (in thousand metric tons of CO2 equivalent) in PFC gas in 2000 to that in 2010?
Give a very brief answer. 1.35. What is the ratio of the Emissions (in thousand metric tons of CO2 equivalent) of Other greenhouse gases in 2005 to that in 2008?
Keep it short and to the point. 0.83. What is the ratio of the Emissions (in thousand metric tons of CO2 equivalent) of SF6 gas in 2005 to that in 2008?
Make the answer very short. 1.03. What is the ratio of the Emissions (in thousand metric tons of CO2 equivalent) of HFC gas in 2005 to that in 2008?
Your answer should be very brief. 0.77. What is the ratio of the Emissions (in thousand metric tons of CO2 equivalent) of PFC gas in 2005 to that in 2008?
Make the answer very short. 1.17. What is the ratio of the Emissions (in thousand metric tons of CO2 equivalent) of Other greenhouse gases in 2005 to that in 2010?
Your answer should be compact. 0.75. What is the ratio of the Emissions (in thousand metric tons of CO2 equivalent) in SF6 gas in 2005 to that in 2010?
Provide a succinct answer. 1.2. What is the ratio of the Emissions (in thousand metric tons of CO2 equivalent) in HFC gas in 2005 to that in 2010?
Offer a terse response. 0.68. What is the ratio of the Emissions (in thousand metric tons of CO2 equivalent) of PFC gas in 2005 to that in 2010?
Provide a succinct answer. 1.14. What is the ratio of the Emissions (in thousand metric tons of CO2 equivalent) in Other greenhouse gases in 2008 to that in 2010?
Your answer should be compact. 0.9. What is the ratio of the Emissions (in thousand metric tons of CO2 equivalent) in SF6 gas in 2008 to that in 2010?
Ensure brevity in your answer.  1.16. What is the ratio of the Emissions (in thousand metric tons of CO2 equivalent) of HFC gas in 2008 to that in 2010?
Ensure brevity in your answer.  0.88. What is the ratio of the Emissions (in thousand metric tons of CO2 equivalent) of PFC gas in 2008 to that in 2010?
Your response must be concise. 0.97. What is the difference between the highest and the second highest Emissions (in thousand metric tons of CO2 equivalent) in Other greenhouse gases?
Keep it short and to the point. 7042.3. What is the difference between the highest and the second highest Emissions (in thousand metric tons of CO2 equivalent) in SF6 gas?
Your answer should be very brief. 7269.2. What is the difference between the highest and the second highest Emissions (in thousand metric tons of CO2 equivalent) of HFC gas?
Your answer should be very brief. 7446.1. What is the difference between the highest and the second highest Emissions (in thousand metric tons of CO2 equivalent) of PFC gas?
Give a very brief answer. 1406.2. What is the difference between the highest and the lowest Emissions (in thousand metric tons of CO2 equivalent) of Other greenhouse gases?
Offer a very short reply. 4.25e+04. What is the difference between the highest and the lowest Emissions (in thousand metric tons of CO2 equivalent) in SF6 gas?
Provide a succinct answer. 1.07e+04. What is the difference between the highest and the lowest Emissions (in thousand metric tons of CO2 equivalent) of HFC gas?
Your response must be concise. 5.12e+04. What is the difference between the highest and the lowest Emissions (in thousand metric tons of CO2 equivalent) of PFC gas?
Make the answer very short. 4329.8. 